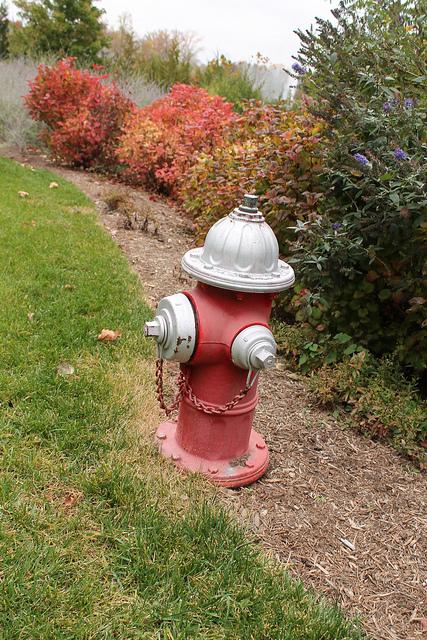Would a dog like this object?
Be succinct. Yes. Does the grass look nice?
Be succinct. No. Is the hydrant 2 different colors?
Keep it brief. Yes. 